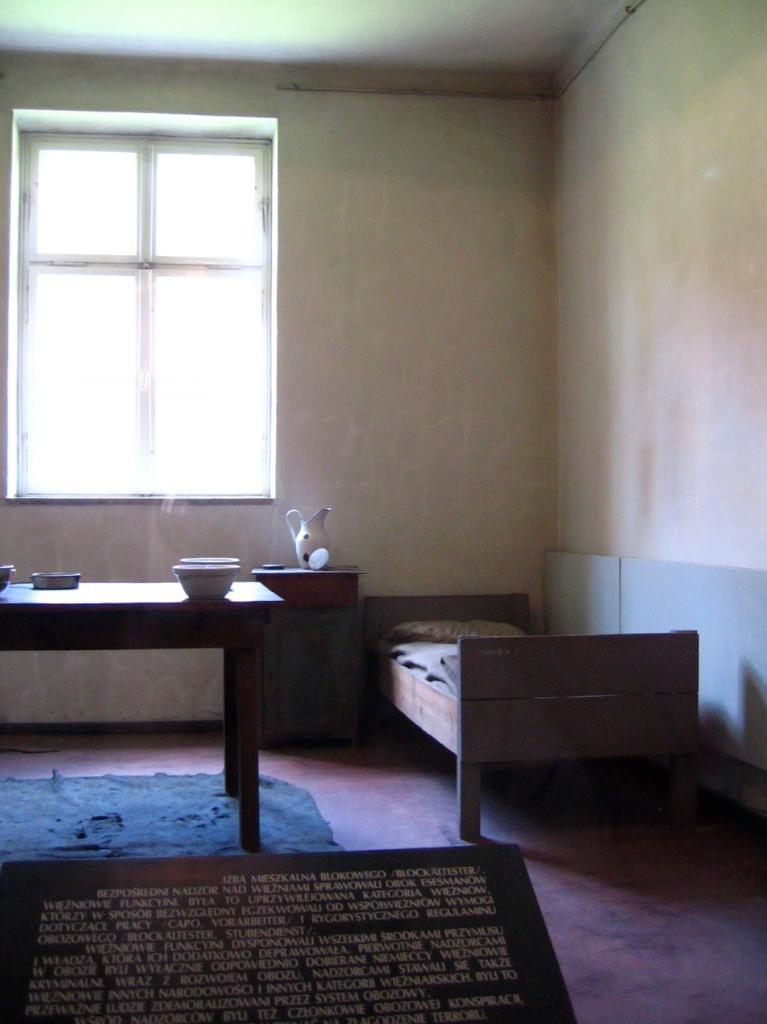Could you give a brief overview of what you see in this image? On the right side of the image we can see a bed placed on the floor. On the left side of the image we can see a jar, some bowls placed on the tables and a window. At the bottom of the image we can see a board with some text. At the top of the image we can see the roof. 